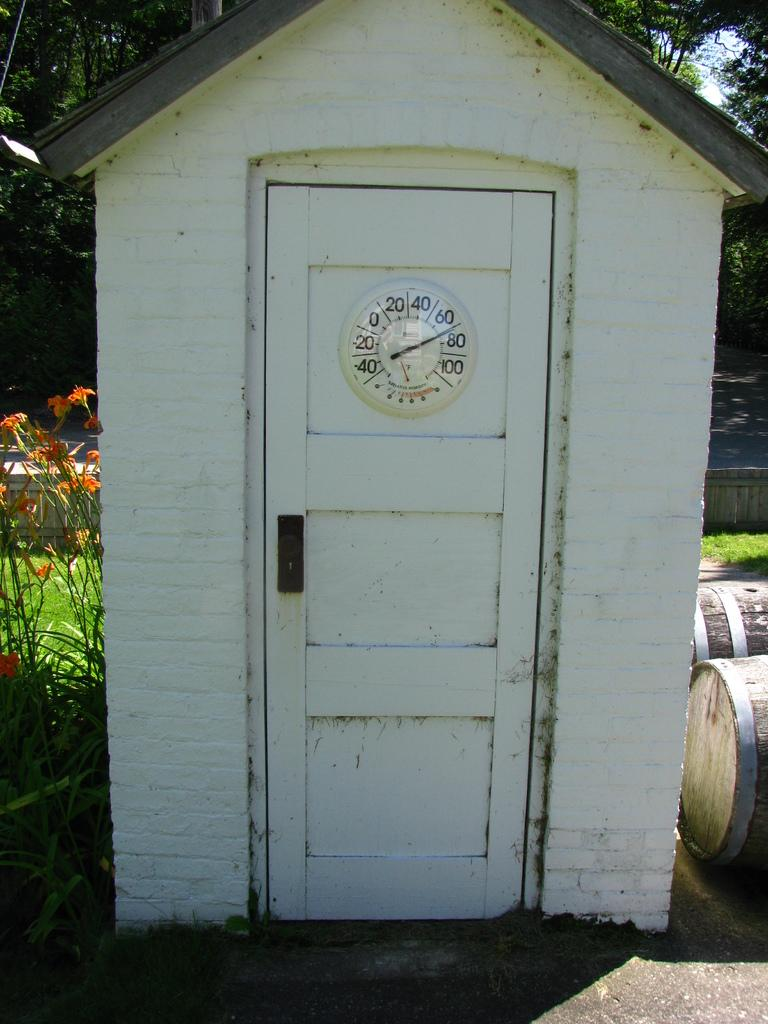<image>
Render a clear and concise summary of the photo. A small outdoor building has a thermometer on the door that show the temperature to be about 71 degrees. 